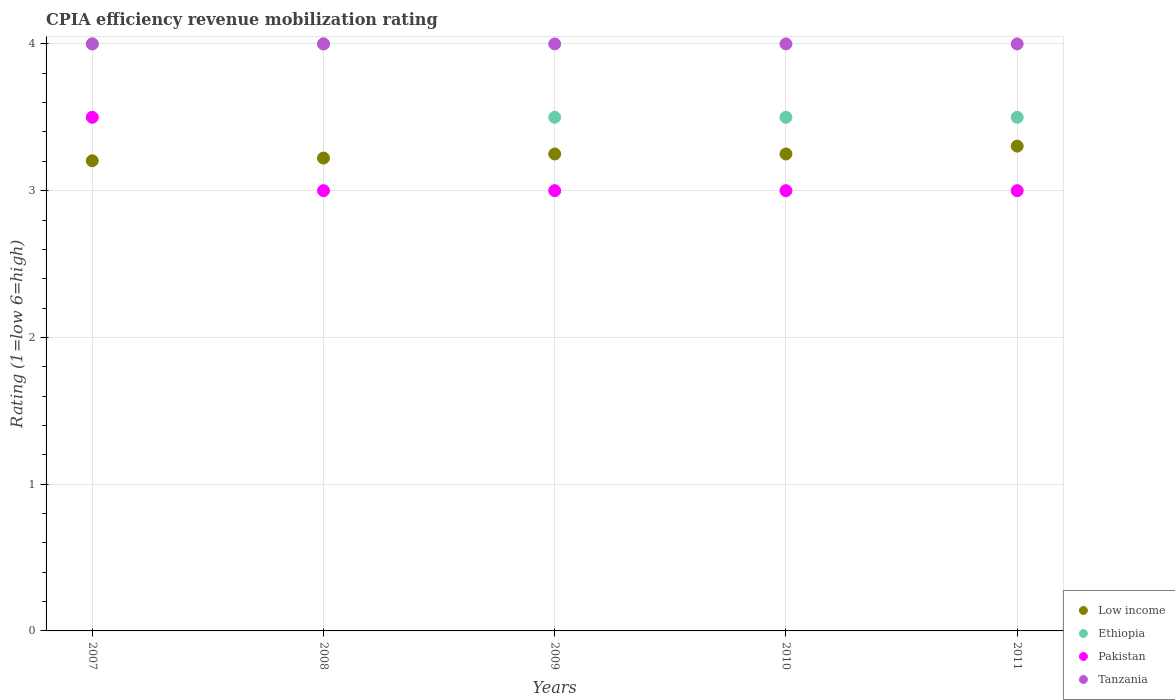How many different coloured dotlines are there?
Give a very brief answer. 4. What is the CPIA rating in Tanzania in 2008?
Make the answer very short. 4. Across all years, what is the minimum CPIA rating in Tanzania?
Give a very brief answer. 4. What is the total CPIA rating in Ethiopia in the graph?
Offer a very short reply. 18.5. What is the difference between the CPIA rating in Tanzania in 2008 and that in 2011?
Provide a succinct answer. 0. What is the average CPIA rating in Low income per year?
Your answer should be very brief. 3.25. In the year 2007, what is the difference between the CPIA rating in Pakistan and CPIA rating in Tanzania?
Provide a short and direct response. -0.5. In how many years, is the CPIA rating in Pakistan greater than 3.2?
Your answer should be compact. 1. Is the difference between the CPIA rating in Pakistan in 2007 and 2008 greater than the difference between the CPIA rating in Tanzania in 2007 and 2008?
Provide a succinct answer. Yes. In how many years, is the CPIA rating in Low income greater than the average CPIA rating in Low income taken over all years?
Ensure brevity in your answer.  3. Is the sum of the CPIA rating in Tanzania in 2008 and 2011 greater than the maximum CPIA rating in Ethiopia across all years?
Your response must be concise. Yes. Is it the case that in every year, the sum of the CPIA rating in Ethiopia and CPIA rating in Low income  is greater than the sum of CPIA rating in Pakistan and CPIA rating in Tanzania?
Ensure brevity in your answer.  No. Is it the case that in every year, the sum of the CPIA rating in Tanzania and CPIA rating in Pakistan  is greater than the CPIA rating in Low income?
Give a very brief answer. Yes. How many dotlines are there?
Your answer should be very brief. 4. What is the difference between two consecutive major ticks on the Y-axis?
Make the answer very short. 1. Are the values on the major ticks of Y-axis written in scientific E-notation?
Give a very brief answer. No. Does the graph contain grids?
Your response must be concise. Yes. How many legend labels are there?
Your answer should be very brief. 4. How are the legend labels stacked?
Ensure brevity in your answer.  Vertical. What is the title of the graph?
Keep it short and to the point. CPIA efficiency revenue mobilization rating. What is the label or title of the X-axis?
Keep it short and to the point. Years. What is the Rating (1=low 6=high) of Low income in 2007?
Your answer should be very brief. 3.2. What is the Rating (1=low 6=high) in Ethiopia in 2007?
Keep it short and to the point. 4. What is the Rating (1=low 6=high) of Tanzania in 2007?
Make the answer very short. 4. What is the Rating (1=low 6=high) in Low income in 2008?
Your answer should be very brief. 3.22. What is the Rating (1=low 6=high) of Pakistan in 2008?
Keep it short and to the point. 3. What is the Rating (1=low 6=high) in Pakistan in 2009?
Offer a terse response. 3. What is the Rating (1=low 6=high) of Ethiopia in 2010?
Provide a short and direct response. 3.5. What is the Rating (1=low 6=high) of Pakistan in 2010?
Give a very brief answer. 3. What is the Rating (1=low 6=high) in Tanzania in 2010?
Your answer should be compact. 4. What is the Rating (1=low 6=high) in Low income in 2011?
Give a very brief answer. 3.3. Across all years, what is the maximum Rating (1=low 6=high) in Low income?
Ensure brevity in your answer.  3.3. Across all years, what is the maximum Rating (1=low 6=high) of Ethiopia?
Offer a very short reply. 4. Across all years, what is the minimum Rating (1=low 6=high) of Low income?
Offer a very short reply. 3.2. Across all years, what is the minimum Rating (1=low 6=high) in Pakistan?
Your answer should be very brief. 3. What is the total Rating (1=low 6=high) in Low income in the graph?
Your answer should be compact. 16.23. What is the difference between the Rating (1=low 6=high) in Low income in 2007 and that in 2008?
Keep it short and to the point. -0.02. What is the difference between the Rating (1=low 6=high) of Pakistan in 2007 and that in 2008?
Offer a terse response. 0.5. What is the difference between the Rating (1=low 6=high) in Low income in 2007 and that in 2009?
Provide a short and direct response. -0.05. What is the difference between the Rating (1=low 6=high) of Ethiopia in 2007 and that in 2009?
Offer a very short reply. 0.5. What is the difference between the Rating (1=low 6=high) of Low income in 2007 and that in 2010?
Offer a very short reply. -0.05. What is the difference between the Rating (1=low 6=high) of Ethiopia in 2007 and that in 2010?
Give a very brief answer. 0.5. What is the difference between the Rating (1=low 6=high) of Pakistan in 2007 and that in 2010?
Your answer should be very brief. 0.5. What is the difference between the Rating (1=low 6=high) in Tanzania in 2007 and that in 2010?
Your response must be concise. 0. What is the difference between the Rating (1=low 6=high) in Low income in 2007 and that in 2011?
Make the answer very short. -0.1. What is the difference between the Rating (1=low 6=high) of Ethiopia in 2007 and that in 2011?
Provide a short and direct response. 0.5. What is the difference between the Rating (1=low 6=high) of Pakistan in 2007 and that in 2011?
Give a very brief answer. 0.5. What is the difference between the Rating (1=low 6=high) in Low income in 2008 and that in 2009?
Provide a succinct answer. -0.03. What is the difference between the Rating (1=low 6=high) of Ethiopia in 2008 and that in 2009?
Your answer should be compact. 0.5. What is the difference between the Rating (1=low 6=high) of Low income in 2008 and that in 2010?
Provide a short and direct response. -0.03. What is the difference between the Rating (1=low 6=high) in Ethiopia in 2008 and that in 2010?
Ensure brevity in your answer.  0.5. What is the difference between the Rating (1=low 6=high) in Pakistan in 2008 and that in 2010?
Give a very brief answer. 0. What is the difference between the Rating (1=low 6=high) of Tanzania in 2008 and that in 2010?
Your answer should be very brief. 0. What is the difference between the Rating (1=low 6=high) of Low income in 2008 and that in 2011?
Provide a short and direct response. -0.08. What is the difference between the Rating (1=low 6=high) in Pakistan in 2008 and that in 2011?
Your response must be concise. 0. What is the difference between the Rating (1=low 6=high) of Tanzania in 2008 and that in 2011?
Your response must be concise. 0. What is the difference between the Rating (1=low 6=high) in Pakistan in 2009 and that in 2010?
Offer a very short reply. 0. What is the difference between the Rating (1=low 6=high) of Tanzania in 2009 and that in 2010?
Your response must be concise. 0. What is the difference between the Rating (1=low 6=high) of Low income in 2009 and that in 2011?
Offer a very short reply. -0.05. What is the difference between the Rating (1=low 6=high) in Pakistan in 2009 and that in 2011?
Offer a terse response. 0. What is the difference between the Rating (1=low 6=high) in Low income in 2010 and that in 2011?
Make the answer very short. -0.05. What is the difference between the Rating (1=low 6=high) in Low income in 2007 and the Rating (1=low 6=high) in Ethiopia in 2008?
Your response must be concise. -0.8. What is the difference between the Rating (1=low 6=high) in Low income in 2007 and the Rating (1=low 6=high) in Pakistan in 2008?
Ensure brevity in your answer.  0.2. What is the difference between the Rating (1=low 6=high) in Low income in 2007 and the Rating (1=low 6=high) in Tanzania in 2008?
Give a very brief answer. -0.8. What is the difference between the Rating (1=low 6=high) in Pakistan in 2007 and the Rating (1=low 6=high) in Tanzania in 2008?
Keep it short and to the point. -0.5. What is the difference between the Rating (1=low 6=high) of Low income in 2007 and the Rating (1=low 6=high) of Ethiopia in 2009?
Make the answer very short. -0.3. What is the difference between the Rating (1=low 6=high) in Low income in 2007 and the Rating (1=low 6=high) in Pakistan in 2009?
Keep it short and to the point. 0.2. What is the difference between the Rating (1=low 6=high) in Low income in 2007 and the Rating (1=low 6=high) in Tanzania in 2009?
Keep it short and to the point. -0.8. What is the difference between the Rating (1=low 6=high) in Low income in 2007 and the Rating (1=low 6=high) in Ethiopia in 2010?
Provide a short and direct response. -0.3. What is the difference between the Rating (1=low 6=high) in Low income in 2007 and the Rating (1=low 6=high) in Pakistan in 2010?
Your answer should be compact. 0.2. What is the difference between the Rating (1=low 6=high) of Low income in 2007 and the Rating (1=low 6=high) of Tanzania in 2010?
Make the answer very short. -0.8. What is the difference between the Rating (1=low 6=high) in Ethiopia in 2007 and the Rating (1=low 6=high) in Pakistan in 2010?
Give a very brief answer. 1. What is the difference between the Rating (1=low 6=high) in Ethiopia in 2007 and the Rating (1=low 6=high) in Tanzania in 2010?
Your answer should be very brief. 0. What is the difference between the Rating (1=low 6=high) of Low income in 2007 and the Rating (1=low 6=high) of Ethiopia in 2011?
Your answer should be compact. -0.3. What is the difference between the Rating (1=low 6=high) in Low income in 2007 and the Rating (1=low 6=high) in Pakistan in 2011?
Make the answer very short. 0.2. What is the difference between the Rating (1=low 6=high) of Low income in 2007 and the Rating (1=low 6=high) of Tanzania in 2011?
Provide a succinct answer. -0.8. What is the difference between the Rating (1=low 6=high) in Ethiopia in 2007 and the Rating (1=low 6=high) in Tanzania in 2011?
Give a very brief answer. 0. What is the difference between the Rating (1=low 6=high) of Pakistan in 2007 and the Rating (1=low 6=high) of Tanzania in 2011?
Offer a terse response. -0.5. What is the difference between the Rating (1=low 6=high) in Low income in 2008 and the Rating (1=low 6=high) in Ethiopia in 2009?
Your response must be concise. -0.28. What is the difference between the Rating (1=low 6=high) in Low income in 2008 and the Rating (1=low 6=high) in Pakistan in 2009?
Make the answer very short. 0.22. What is the difference between the Rating (1=low 6=high) of Low income in 2008 and the Rating (1=low 6=high) of Tanzania in 2009?
Make the answer very short. -0.78. What is the difference between the Rating (1=low 6=high) of Ethiopia in 2008 and the Rating (1=low 6=high) of Tanzania in 2009?
Give a very brief answer. 0. What is the difference between the Rating (1=low 6=high) in Low income in 2008 and the Rating (1=low 6=high) in Ethiopia in 2010?
Provide a short and direct response. -0.28. What is the difference between the Rating (1=low 6=high) of Low income in 2008 and the Rating (1=low 6=high) of Pakistan in 2010?
Provide a succinct answer. 0.22. What is the difference between the Rating (1=low 6=high) of Low income in 2008 and the Rating (1=low 6=high) of Tanzania in 2010?
Give a very brief answer. -0.78. What is the difference between the Rating (1=low 6=high) of Ethiopia in 2008 and the Rating (1=low 6=high) of Pakistan in 2010?
Give a very brief answer. 1. What is the difference between the Rating (1=low 6=high) of Low income in 2008 and the Rating (1=low 6=high) of Ethiopia in 2011?
Provide a short and direct response. -0.28. What is the difference between the Rating (1=low 6=high) in Low income in 2008 and the Rating (1=low 6=high) in Pakistan in 2011?
Ensure brevity in your answer.  0.22. What is the difference between the Rating (1=low 6=high) in Low income in 2008 and the Rating (1=low 6=high) in Tanzania in 2011?
Offer a terse response. -0.78. What is the difference between the Rating (1=low 6=high) in Ethiopia in 2008 and the Rating (1=low 6=high) in Tanzania in 2011?
Offer a very short reply. 0. What is the difference between the Rating (1=low 6=high) of Pakistan in 2008 and the Rating (1=low 6=high) of Tanzania in 2011?
Provide a succinct answer. -1. What is the difference between the Rating (1=low 6=high) of Low income in 2009 and the Rating (1=low 6=high) of Ethiopia in 2010?
Give a very brief answer. -0.25. What is the difference between the Rating (1=low 6=high) in Low income in 2009 and the Rating (1=low 6=high) in Pakistan in 2010?
Provide a short and direct response. 0.25. What is the difference between the Rating (1=low 6=high) in Low income in 2009 and the Rating (1=low 6=high) in Tanzania in 2010?
Your response must be concise. -0.75. What is the difference between the Rating (1=low 6=high) of Ethiopia in 2009 and the Rating (1=low 6=high) of Pakistan in 2010?
Provide a short and direct response. 0.5. What is the difference between the Rating (1=low 6=high) of Ethiopia in 2009 and the Rating (1=low 6=high) of Tanzania in 2010?
Offer a very short reply. -0.5. What is the difference between the Rating (1=low 6=high) in Low income in 2009 and the Rating (1=low 6=high) in Ethiopia in 2011?
Make the answer very short. -0.25. What is the difference between the Rating (1=low 6=high) of Low income in 2009 and the Rating (1=low 6=high) of Tanzania in 2011?
Provide a succinct answer. -0.75. What is the difference between the Rating (1=low 6=high) of Ethiopia in 2009 and the Rating (1=low 6=high) of Tanzania in 2011?
Offer a terse response. -0.5. What is the difference between the Rating (1=low 6=high) in Pakistan in 2009 and the Rating (1=low 6=high) in Tanzania in 2011?
Make the answer very short. -1. What is the difference between the Rating (1=low 6=high) of Low income in 2010 and the Rating (1=low 6=high) of Ethiopia in 2011?
Offer a very short reply. -0.25. What is the difference between the Rating (1=low 6=high) of Low income in 2010 and the Rating (1=low 6=high) of Tanzania in 2011?
Ensure brevity in your answer.  -0.75. What is the difference between the Rating (1=low 6=high) in Ethiopia in 2010 and the Rating (1=low 6=high) in Pakistan in 2011?
Offer a terse response. 0.5. What is the difference between the Rating (1=low 6=high) in Ethiopia in 2010 and the Rating (1=low 6=high) in Tanzania in 2011?
Provide a succinct answer. -0.5. What is the difference between the Rating (1=low 6=high) of Pakistan in 2010 and the Rating (1=low 6=high) of Tanzania in 2011?
Offer a very short reply. -1. What is the average Rating (1=low 6=high) of Low income per year?
Provide a short and direct response. 3.25. What is the average Rating (1=low 6=high) of Ethiopia per year?
Your response must be concise. 3.7. In the year 2007, what is the difference between the Rating (1=low 6=high) of Low income and Rating (1=low 6=high) of Ethiopia?
Keep it short and to the point. -0.8. In the year 2007, what is the difference between the Rating (1=low 6=high) in Low income and Rating (1=low 6=high) in Pakistan?
Give a very brief answer. -0.3. In the year 2007, what is the difference between the Rating (1=low 6=high) of Low income and Rating (1=low 6=high) of Tanzania?
Offer a terse response. -0.8. In the year 2007, what is the difference between the Rating (1=low 6=high) of Ethiopia and Rating (1=low 6=high) of Pakistan?
Provide a short and direct response. 0.5. In the year 2008, what is the difference between the Rating (1=low 6=high) in Low income and Rating (1=low 6=high) in Ethiopia?
Your response must be concise. -0.78. In the year 2008, what is the difference between the Rating (1=low 6=high) of Low income and Rating (1=low 6=high) of Pakistan?
Offer a terse response. 0.22. In the year 2008, what is the difference between the Rating (1=low 6=high) of Low income and Rating (1=low 6=high) of Tanzania?
Provide a succinct answer. -0.78. In the year 2008, what is the difference between the Rating (1=low 6=high) of Ethiopia and Rating (1=low 6=high) of Tanzania?
Your answer should be compact. 0. In the year 2008, what is the difference between the Rating (1=low 6=high) in Pakistan and Rating (1=low 6=high) in Tanzania?
Offer a very short reply. -1. In the year 2009, what is the difference between the Rating (1=low 6=high) of Low income and Rating (1=low 6=high) of Ethiopia?
Keep it short and to the point. -0.25. In the year 2009, what is the difference between the Rating (1=low 6=high) in Low income and Rating (1=low 6=high) in Pakistan?
Provide a succinct answer. 0.25. In the year 2009, what is the difference between the Rating (1=low 6=high) in Low income and Rating (1=low 6=high) in Tanzania?
Ensure brevity in your answer.  -0.75. In the year 2009, what is the difference between the Rating (1=low 6=high) of Ethiopia and Rating (1=low 6=high) of Pakistan?
Keep it short and to the point. 0.5. In the year 2009, what is the difference between the Rating (1=low 6=high) in Ethiopia and Rating (1=low 6=high) in Tanzania?
Your response must be concise. -0.5. In the year 2010, what is the difference between the Rating (1=low 6=high) in Low income and Rating (1=low 6=high) in Pakistan?
Offer a terse response. 0.25. In the year 2010, what is the difference between the Rating (1=low 6=high) in Low income and Rating (1=low 6=high) in Tanzania?
Make the answer very short. -0.75. In the year 2011, what is the difference between the Rating (1=low 6=high) of Low income and Rating (1=low 6=high) of Ethiopia?
Provide a short and direct response. -0.2. In the year 2011, what is the difference between the Rating (1=low 6=high) in Low income and Rating (1=low 6=high) in Pakistan?
Give a very brief answer. 0.3. In the year 2011, what is the difference between the Rating (1=low 6=high) in Low income and Rating (1=low 6=high) in Tanzania?
Your answer should be very brief. -0.7. In the year 2011, what is the difference between the Rating (1=low 6=high) in Ethiopia and Rating (1=low 6=high) in Pakistan?
Your answer should be very brief. 0.5. In the year 2011, what is the difference between the Rating (1=low 6=high) in Ethiopia and Rating (1=low 6=high) in Tanzania?
Your answer should be compact. -0.5. In the year 2011, what is the difference between the Rating (1=low 6=high) of Pakistan and Rating (1=low 6=high) of Tanzania?
Provide a succinct answer. -1. What is the ratio of the Rating (1=low 6=high) in Low income in 2007 to that in 2008?
Give a very brief answer. 0.99. What is the ratio of the Rating (1=low 6=high) in Ethiopia in 2007 to that in 2008?
Your answer should be compact. 1. What is the ratio of the Rating (1=low 6=high) in Pakistan in 2007 to that in 2008?
Keep it short and to the point. 1.17. What is the ratio of the Rating (1=low 6=high) in Low income in 2007 to that in 2009?
Your answer should be very brief. 0.99. What is the ratio of the Rating (1=low 6=high) of Ethiopia in 2007 to that in 2009?
Your answer should be compact. 1.14. What is the ratio of the Rating (1=low 6=high) of Pakistan in 2007 to that in 2009?
Ensure brevity in your answer.  1.17. What is the ratio of the Rating (1=low 6=high) of Tanzania in 2007 to that in 2009?
Provide a short and direct response. 1. What is the ratio of the Rating (1=low 6=high) in Low income in 2007 to that in 2010?
Your answer should be very brief. 0.99. What is the ratio of the Rating (1=low 6=high) in Pakistan in 2007 to that in 2010?
Your answer should be compact. 1.17. What is the ratio of the Rating (1=low 6=high) in Tanzania in 2007 to that in 2010?
Offer a very short reply. 1. What is the ratio of the Rating (1=low 6=high) in Low income in 2007 to that in 2011?
Provide a short and direct response. 0.97. What is the ratio of the Rating (1=low 6=high) in Ethiopia in 2007 to that in 2011?
Ensure brevity in your answer.  1.14. What is the ratio of the Rating (1=low 6=high) of Low income in 2008 to that in 2009?
Give a very brief answer. 0.99. What is the ratio of the Rating (1=low 6=high) of Ethiopia in 2008 to that in 2009?
Your answer should be compact. 1.14. What is the ratio of the Rating (1=low 6=high) in Pakistan in 2008 to that in 2009?
Give a very brief answer. 1. What is the ratio of the Rating (1=low 6=high) of Tanzania in 2008 to that in 2009?
Keep it short and to the point. 1. What is the ratio of the Rating (1=low 6=high) in Low income in 2008 to that in 2010?
Provide a short and direct response. 0.99. What is the ratio of the Rating (1=low 6=high) of Low income in 2008 to that in 2011?
Give a very brief answer. 0.98. What is the ratio of the Rating (1=low 6=high) in Ethiopia in 2008 to that in 2011?
Your answer should be very brief. 1.14. What is the ratio of the Rating (1=low 6=high) of Tanzania in 2008 to that in 2011?
Keep it short and to the point. 1. What is the ratio of the Rating (1=low 6=high) in Low income in 2009 to that in 2010?
Offer a terse response. 1. What is the ratio of the Rating (1=low 6=high) in Low income in 2009 to that in 2011?
Give a very brief answer. 0.98. What is the ratio of the Rating (1=low 6=high) of Pakistan in 2009 to that in 2011?
Offer a very short reply. 1. What is the ratio of the Rating (1=low 6=high) in Low income in 2010 to that in 2011?
Your answer should be compact. 0.98. What is the ratio of the Rating (1=low 6=high) of Tanzania in 2010 to that in 2011?
Provide a succinct answer. 1. What is the difference between the highest and the second highest Rating (1=low 6=high) in Low income?
Ensure brevity in your answer.  0.05. What is the difference between the highest and the second highest Rating (1=low 6=high) in Ethiopia?
Your response must be concise. 0. What is the difference between the highest and the second highest Rating (1=low 6=high) of Pakistan?
Your answer should be compact. 0.5. What is the difference between the highest and the second highest Rating (1=low 6=high) in Tanzania?
Your answer should be compact. 0. What is the difference between the highest and the lowest Rating (1=low 6=high) of Low income?
Your answer should be compact. 0.1. What is the difference between the highest and the lowest Rating (1=low 6=high) of Ethiopia?
Offer a terse response. 0.5. 